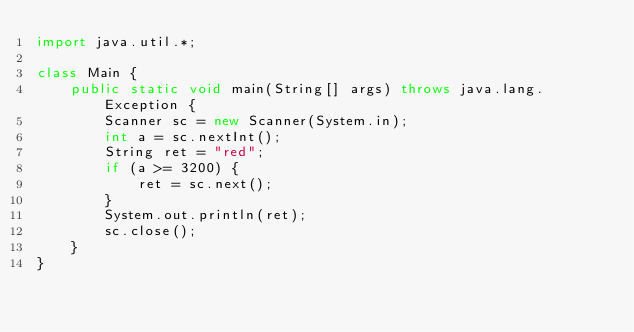Convert code to text. <code><loc_0><loc_0><loc_500><loc_500><_Java_>import java.util.*;

class Main {
    public static void main(String[] args) throws java.lang.Exception {
        Scanner sc = new Scanner(System.in);
        int a = sc.nextInt();
        String ret = "red";
        if (a >= 3200) {
            ret = sc.next();
        }
        System.out.println(ret);
        sc.close();
    }
}
</code> 